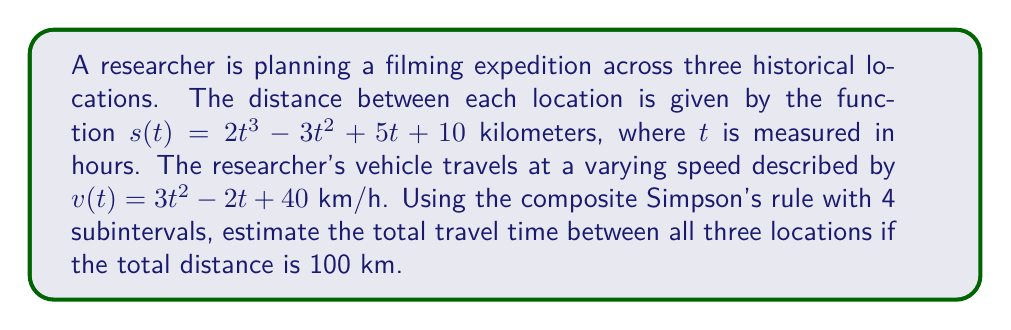Could you help me with this problem? To solve this problem, we need to use numerical integration to estimate the travel time. We'll follow these steps:

1) The time taken is given by the integral of $\frac{1}{v(t)}$ with respect to distance:

   $T = \int_0^{100} \frac{1}{v(t)} ds$

2) We need to change the variable of integration from $s$ to $t$. We know that $\frac{ds}{dt} = s'(t)$, so:

   $T = \int_0^{t_{final}} \frac{1}{v(t)} \cdot s'(t) dt$

3) Calculate $s'(t)$:
   $s'(t) = 6t^2 - 6t + 5$

4) Our integrand is now:
   $f(t) = \frac{6t^2 - 6t + 5}{3t^2 - 2t + 40}$

5) To apply Simpson's rule, we need to find $t_{final}$. We can do this by solving $s(t) = 100$:

   $2t^3 - 3t^2 + 5t + 10 = 100$
   $2t^3 - 3t^2 + 5t - 90 = 0$

   Solving this numerically (e.g., using Newton's method) gives $t_{final} \approx 4.2815$ hours.

6) Now we can apply the composite Simpson's rule with 4 subintervals:

   $\int_a^b f(x) dx \approx \frac{h}{3}[f(x_0) + 4f(x_1) + 2f(x_2) + 4f(x_3) + f(x_4)]$

   Where $h = \frac{b-a}{4} = \frac{4.2815}{4} = 1.070375$

7) Calculate the function values:
   $f(0) = 0.125$
   $f(1.070375) = 0.131690$
   $f(2.14075) = 0.134862$
   $f(3.211125) = 0.136355$
   $f(4.2815) = 0.137083$

8) Applying Simpson's rule:

   $T \approx \frac{1.070375}{3}[0.125 + 4(0.131690) + 2(0.134862) + 4(0.136355) + 0.137083]$
   $T \approx 0.5771$ hours
Answer: 0.5771 hours 